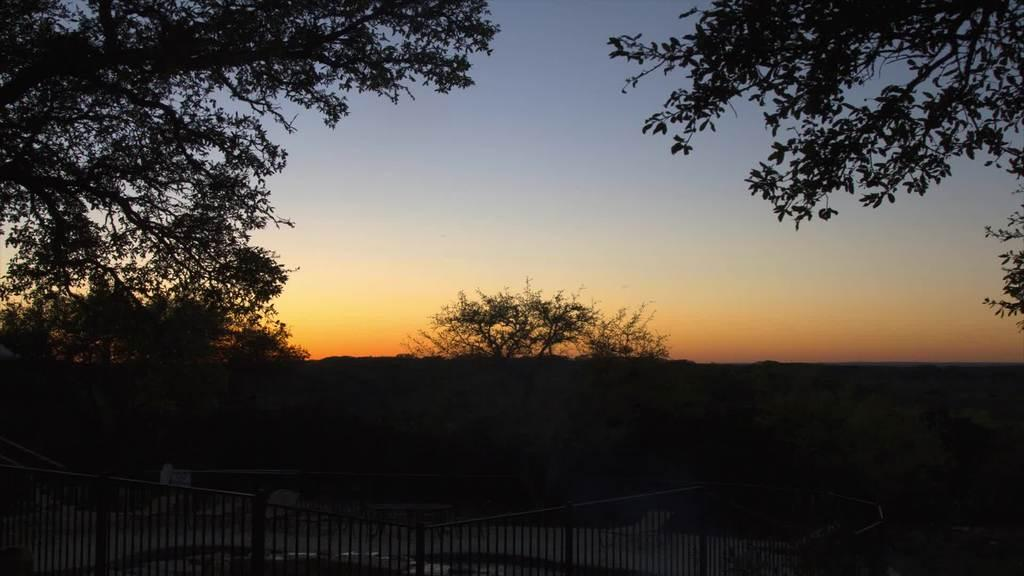What type of structure can be seen in the image? There is an iron railing in the image. What type of vegetation is present in the image? There are trees in the image. What can be seen in the background of the image? The sky is visible in the background of the image. How many times does the mouth open and close during the earthquake in the image? There is no mouth or earthquake present in the image. What type of bit is used by the trees in the image? There are no bits associated with the trees in the image; they are natural vegetation. 